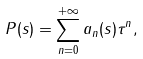<formula> <loc_0><loc_0><loc_500><loc_500>P ( s ) = \sum _ { n = 0 } ^ { + \infty } a _ { n } ( s ) \tau ^ { n } ,</formula> 